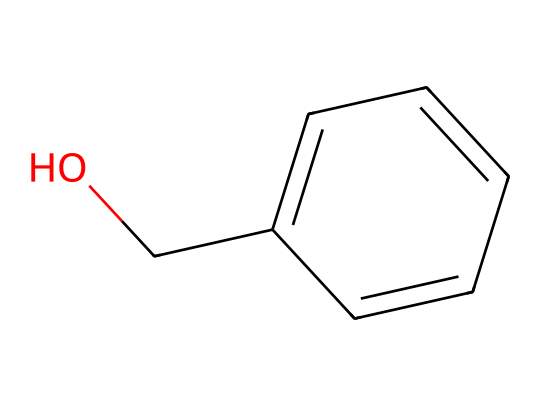What is the molecular formula of benzyl alcohol? The SMILES representation shows a benzene ring with an alcohol group (hydroxyl group) attached. The ring suggests six carbon atoms, and the hydroxyl (OH) indicates one oxygen and one hydrogen atom. Therefore, counting all the atoms gives us a molecular formula of C7H8O.
Answer: C7H8O How many carbon atoms are present in benzyl alcohol? The structure of benzyl alcohol includes a benzene ring, which has six carbon atoms, and one additional carbon from the side chain (the alcohol), totaling seven carbon atoms.
Answer: 7 What type of functional group is present in benzyl alcohol? The SMILES indicates an -OH group attached to the benzene structure, identifying it as an alcohol since the presence of the hydroxyl (-OH) group characterizes this functional group.
Answer: alcohol Why is benzyl alcohol used in cosmetic products? Benzyl alcohol is often used as a preservative in cosmetics due to its antibacterial and antifungal properties. It helps to prevent microbial growth and spoilage of products, ensuring they remain safe for use. The structure’s hydroxyl group contributes to its solubility in cosmetic formulations.
Answer: preservative What is the primary role of the hydroxyl group in benzyl alcohol? The hydroxyl group (-OH) in benzyl alcohol is crucial for its chemical behavior; it not only classifies the compound as an alcohol but also influences its reactivity and solubility in water-based formulations, allowing it to interact positively with skin in cosmetic applications.
Answer: solubility Does benzyl alcohol possess aromatic characteristics? Yes, benzyl alcohol contains a benzene ring, which is characteristic of aromatic compounds. The cyclic structure with alternating double bonds provides stability and imparts aromatic properties to the compound.
Answer: Yes 